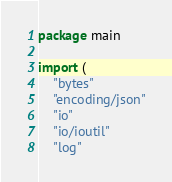Convert code to text. <code><loc_0><loc_0><loc_500><loc_500><_Go_>package main

import (
	"bytes"
	"encoding/json"
	"io"
	"io/ioutil"
	"log"</code> 